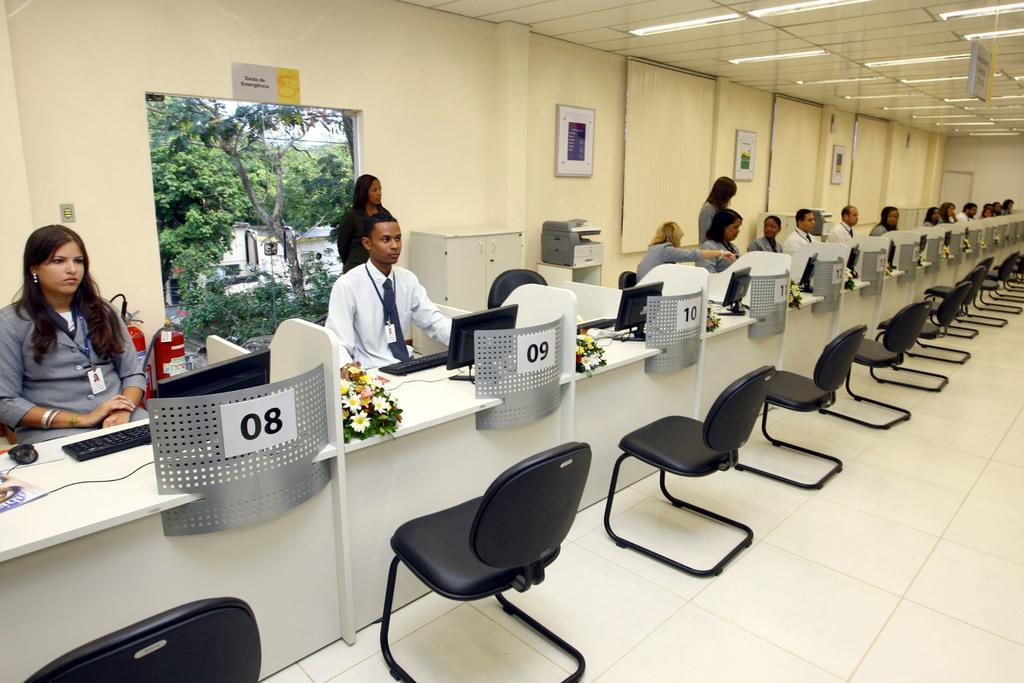Could you give a brief overview of what you see in this image? As we can see in the image there is a wall, photo frames, chairs and few people sitting on chairs and there are mouse, keyboard, laptop and bouquets. 